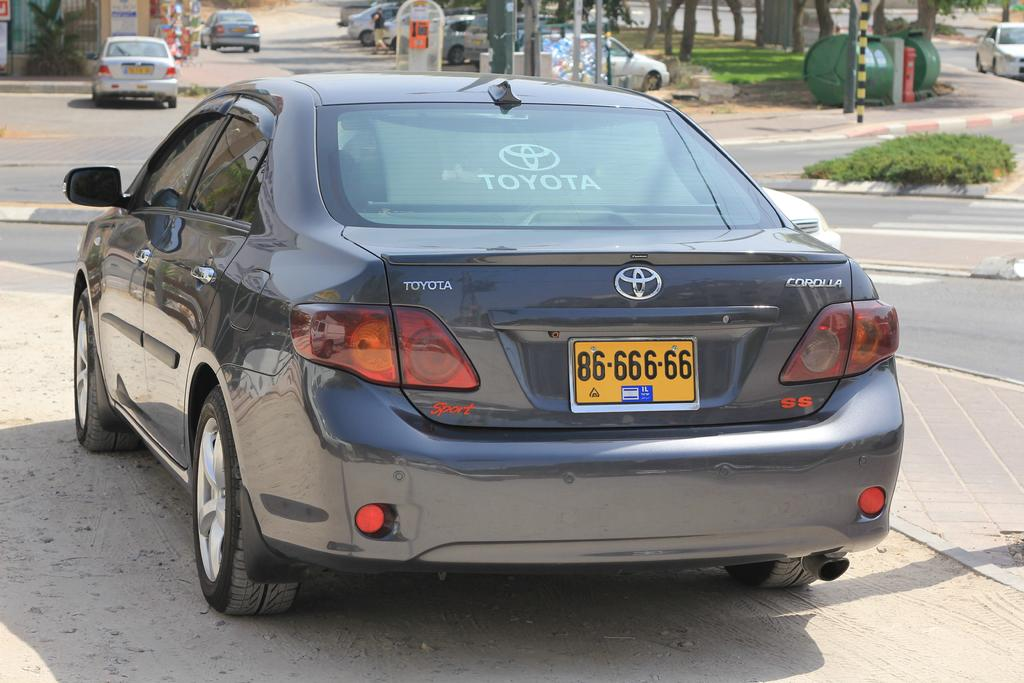Provide a one-sentence caption for the provided image. A black Toyota Corolla with orange license plate. 